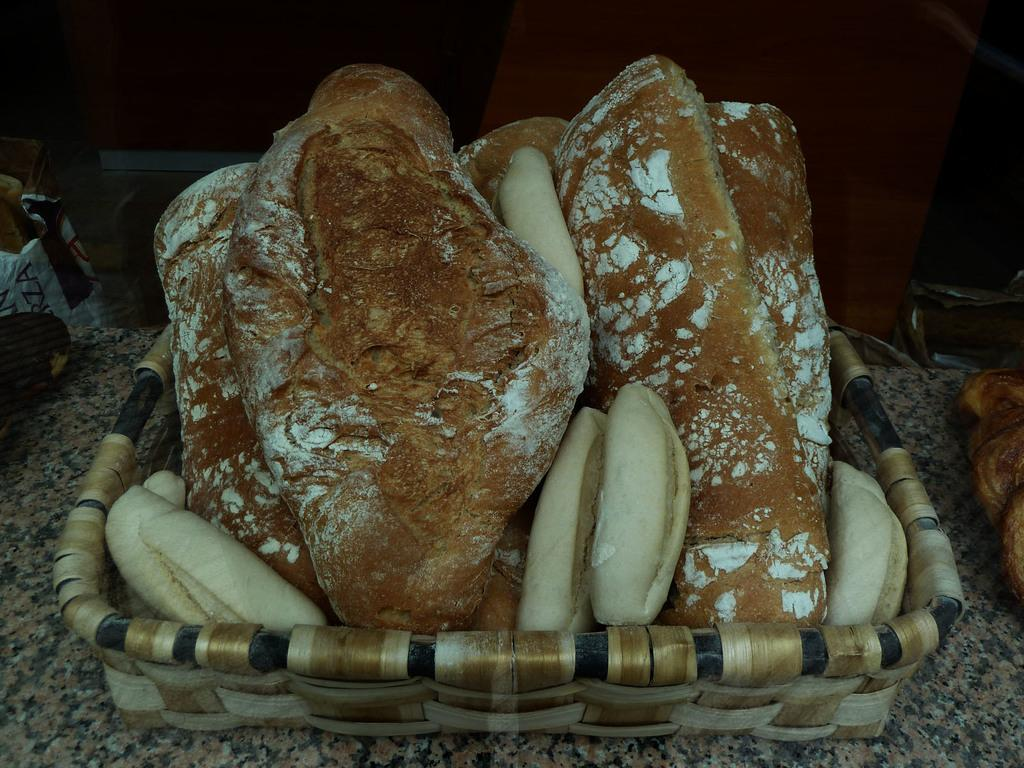What is present in the image? There are food items in the image. How are the food items arranged or contained in the image? The food items are kept in a basket. Where is the basket located in the image? The basket is in the middle of the image. What type of knowledge can be gained from the rain in the image? There is no rain present in the image, so no knowledge can be gained from it. How many friends are visible in the image? There are no friends visible in the image; it features food items in a basket. 